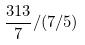<formula> <loc_0><loc_0><loc_500><loc_500>\frac { 3 1 3 } { 7 } / ( 7 / 5 )</formula> 